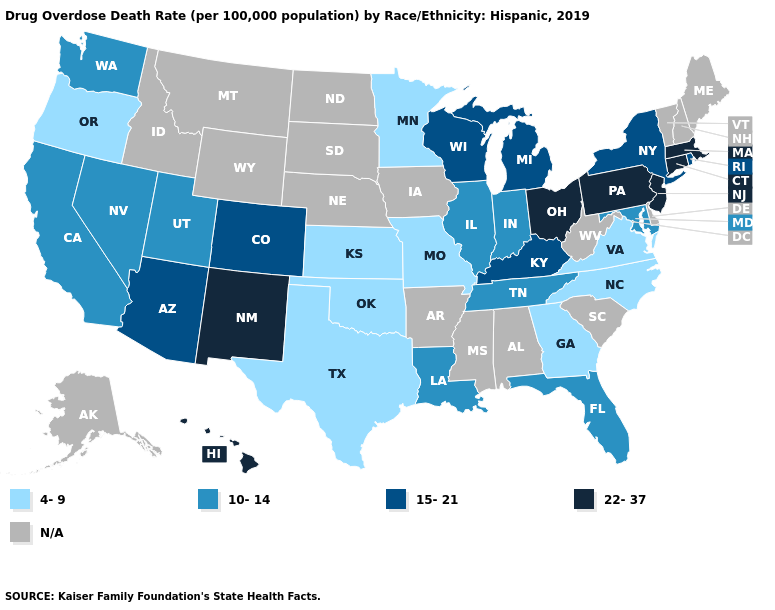How many symbols are there in the legend?
Keep it brief. 5. Which states have the highest value in the USA?
Give a very brief answer. Connecticut, Hawaii, Massachusetts, New Jersey, New Mexico, Ohio, Pennsylvania. What is the value of Kentucky?
Write a very short answer. 15-21. What is the value of Georgia?
Be succinct. 4-9. What is the value of Indiana?
Be succinct. 10-14. What is the lowest value in the South?
Be succinct. 4-9. Is the legend a continuous bar?
Be succinct. No. Name the states that have a value in the range 15-21?
Be succinct. Arizona, Colorado, Kentucky, Michigan, New York, Rhode Island, Wisconsin. What is the value of Nebraska?
Write a very short answer. N/A. Which states have the lowest value in the USA?
Write a very short answer. Georgia, Kansas, Minnesota, Missouri, North Carolina, Oklahoma, Oregon, Texas, Virginia. What is the highest value in states that border North Carolina?
Concise answer only. 10-14. What is the lowest value in the USA?
Write a very short answer. 4-9. Does the first symbol in the legend represent the smallest category?
Write a very short answer. Yes. What is the lowest value in the USA?
Answer briefly. 4-9. 